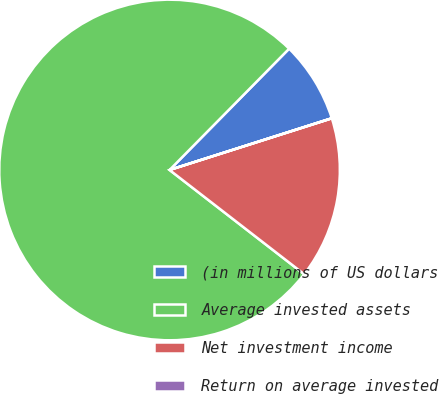Convert chart to OTSL. <chart><loc_0><loc_0><loc_500><loc_500><pie_chart><fcel>(in millions of US dollars<fcel>Average invested assets<fcel>Net investment income<fcel>Return on average invested<nl><fcel>7.7%<fcel>76.91%<fcel>15.39%<fcel>0.01%<nl></chart> 